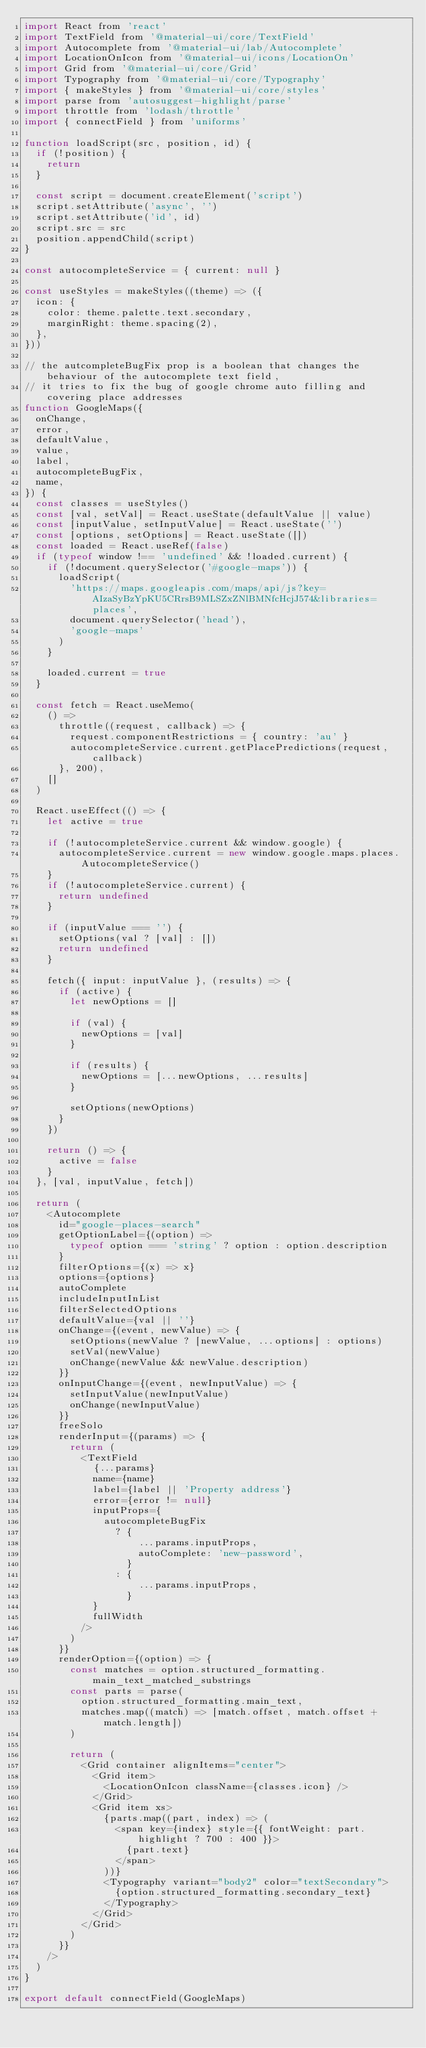Convert code to text. <code><loc_0><loc_0><loc_500><loc_500><_JavaScript_>import React from 'react'
import TextField from '@material-ui/core/TextField'
import Autocomplete from '@material-ui/lab/Autocomplete'
import LocationOnIcon from '@material-ui/icons/LocationOn'
import Grid from '@material-ui/core/Grid'
import Typography from '@material-ui/core/Typography'
import { makeStyles } from '@material-ui/core/styles'
import parse from 'autosuggest-highlight/parse'
import throttle from 'lodash/throttle'
import { connectField } from 'uniforms'

function loadScript(src, position, id) {
  if (!position) {
    return
  }

  const script = document.createElement('script')
  script.setAttribute('async', '')
  script.setAttribute('id', id)
  script.src = src
  position.appendChild(script)
}

const autocompleteService = { current: null }

const useStyles = makeStyles((theme) => ({
  icon: {
    color: theme.palette.text.secondary,
    marginRight: theme.spacing(2),
  },
}))

// the autcompleteBugFix prop is a boolean that changes the behaviour of the autocomplete text field,
// it tries to fix the bug of google chrome auto filling and covering place addresses
function GoogleMaps({
  onChange,
  error,
  defaultValue,
  value,
  label,
  autocompleteBugFix,
  name,
}) {
  const classes = useStyles()
  const [val, setVal] = React.useState(defaultValue || value)
  const [inputValue, setInputValue] = React.useState('')
  const [options, setOptions] = React.useState([])
  const loaded = React.useRef(false)
  if (typeof window !== 'undefined' && !loaded.current) {
    if (!document.querySelector('#google-maps')) {
      loadScript(
        'https://maps.googleapis.com/maps/api/js?key=AIzaSyBzYpKU5CRrsB9MLSZxZNlBMNfcHcjJ574&libraries=places',
        document.querySelector('head'),
        'google-maps'
      )
    }

    loaded.current = true
  }

  const fetch = React.useMemo(
    () =>
      throttle((request, callback) => {
        request.componentRestrictions = { country: 'au' }
        autocompleteService.current.getPlacePredictions(request, callback)
      }, 200),
    []
  )

  React.useEffect(() => {
    let active = true

    if (!autocompleteService.current && window.google) {
      autocompleteService.current = new window.google.maps.places.AutocompleteService()
    }
    if (!autocompleteService.current) {
      return undefined
    }

    if (inputValue === '') {
      setOptions(val ? [val] : [])
      return undefined
    }

    fetch({ input: inputValue }, (results) => {
      if (active) {
        let newOptions = []

        if (val) {
          newOptions = [val]
        }

        if (results) {
          newOptions = [...newOptions, ...results]
        }

        setOptions(newOptions)
      }
    })

    return () => {
      active = false
    }
  }, [val, inputValue, fetch])

  return (
    <Autocomplete
      id="google-places-search"
      getOptionLabel={(option) =>
        typeof option === 'string' ? option : option.description
      }
      filterOptions={(x) => x}
      options={options}
      autoComplete
      includeInputInList
      filterSelectedOptions
      defaultValue={val || ''}
      onChange={(event, newValue) => {
        setOptions(newValue ? [newValue, ...options] : options)
        setVal(newValue)
        onChange(newValue && newValue.description)
      }}
      onInputChange={(event, newInputValue) => {
        setInputValue(newInputValue)
        onChange(newInputValue)
      }}
      freeSolo
      renderInput={(params) => {
        return (
          <TextField
            {...params}
            name={name}
            label={label || 'Property address'}
            error={error != null}
            inputProps={
              autocompleteBugFix
                ? {
                    ...params.inputProps,
                    autoComplete: 'new-password',
                  }
                : {
                    ...params.inputProps,
                  }
            }
            fullWidth
          />
        )
      }}
      renderOption={(option) => {
        const matches = option.structured_formatting.main_text_matched_substrings
        const parts = parse(
          option.structured_formatting.main_text,
          matches.map((match) => [match.offset, match.offset + match.length])
        )

        return (
          <Grid container alignItems="center">
            <Grid item>
              <LocationOnIcon className={classes.icon} />
            </Grid>
            <Grid item xs>
              {parts.map((part, index) => (
                <span key={index} style={{ fontWeight: part.highlight ? 700 : 400 }}>
                  {part.text}
                </span>
              ))}
              <Typography variant="body2" color="textSecondary">
                {option.structured_formatting.secondary_text}
              </Typography>
            </Grid>
          </Grid>
        )
      }}
    />
  )
}

export default connectField(GoogleMaps)
</code> 